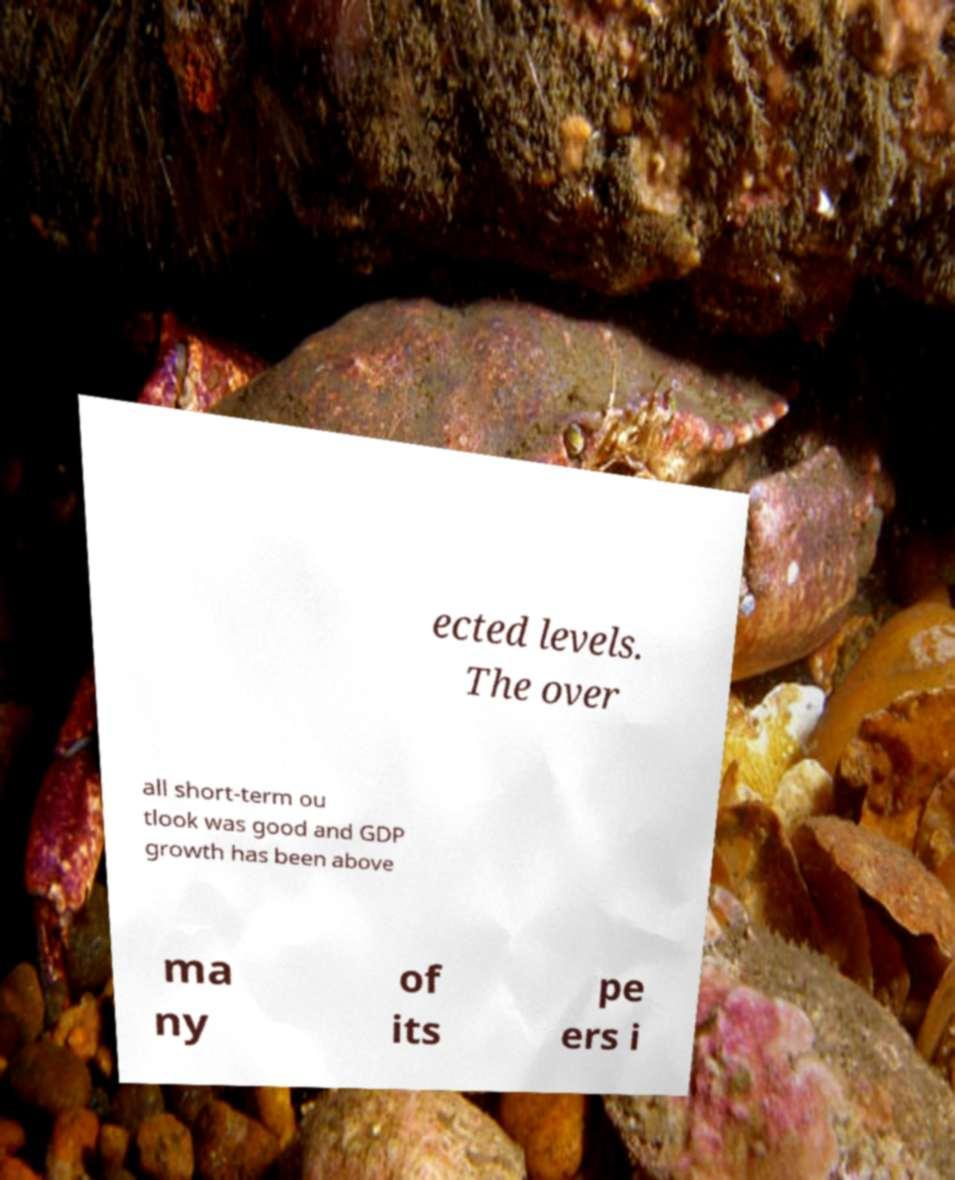Could you assist in decoding the text presented in this image and type it out clearly? ected levels. The over all short-term ou tlook was good and GDP growth has been above ma ny of its pe ers i 